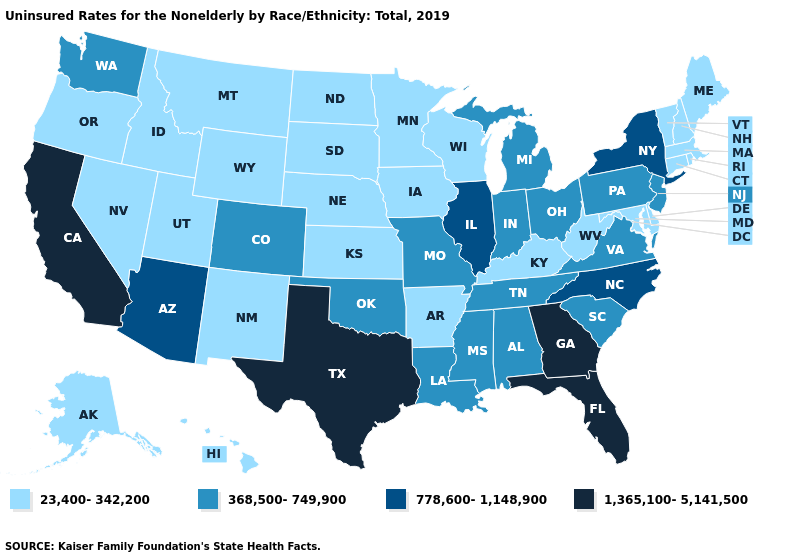Name the states that have a value in the range 368,500-749,900?
Be succinct. Alabama, Colorado, Indiana, Louisiana, Michigan, Mississippi, Missouri, New Jersey, Ohio, Oklahoma, Pennsylvania, South Carolina, Tennessee, Virginia, Washington. Name the states that have a value in the range 368,500-749,900?
Keep it brief. Alabama, Colorado, Indiana, Louisiana, Michigan, Mississippi, Missouri, New Jersey, Ohio, Oklahoma, Pennsylvania, South Carolina, Tennessee, Virginia, Washington. Among the states that border Michigan , which have the lowest value?
Keep it brief. Wisconsin. What is the value of Utah?
Answer briefly. 23,400-342,200. What is the value of Oregon?
Be succinct. 23,400-342,200. Among the states that border Virginia , which have the lowest value?
Concise answer only. Kentucky, Maryland, West Virginia. Is the legend a continuous bar?
Give a very brief answer. No. Name the states that have a value in the range 23,400-342,200?
Quick response, please. Alaska, Arkansas, Connecticut, Delaware, Hawaii, Idaho, Iowa, Kansas, Kentucky, Maine, Maryland, Massachusetts, Minnesota, Montana, Nebraska, Nevada, New Hampshire, New Mexico, North Dakota, Oregon, Rhode Island, South Dakota, Utah, Vermont, West Virginia, Wisconsin, Wyoming. Does New York have the highest value in the Northeast?
Keep it brief. Yes. What is the lowest value in the MidWest?
Be succinct. 23,400-342,200. What is the highest value in the USA?
Concise answer only. 1,365,100-5,141,500. What is the value of New Hampshire?
Short answer required. 23,400-342,200. Does the first symbol in the legend represent the smallest category?
Quick response, please. Yes. Among the states that border Mississippi , which have the lowest value?
Short answer required. Arkansas. What is the value of Montana?
Short answer required. 23,400-342,200. 